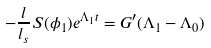Convert formula to latex. <formula><loc_0><loc_0><loc_500><loc_500>- \frac { l } { l _ { s } } S ( \phi _ { 1 } ) e ^ { \Lambda _ { 1 } t } = G ^ { \prime } ( \Lambda _ { 1 } - \Lambda _ { 0 } )</formula> 